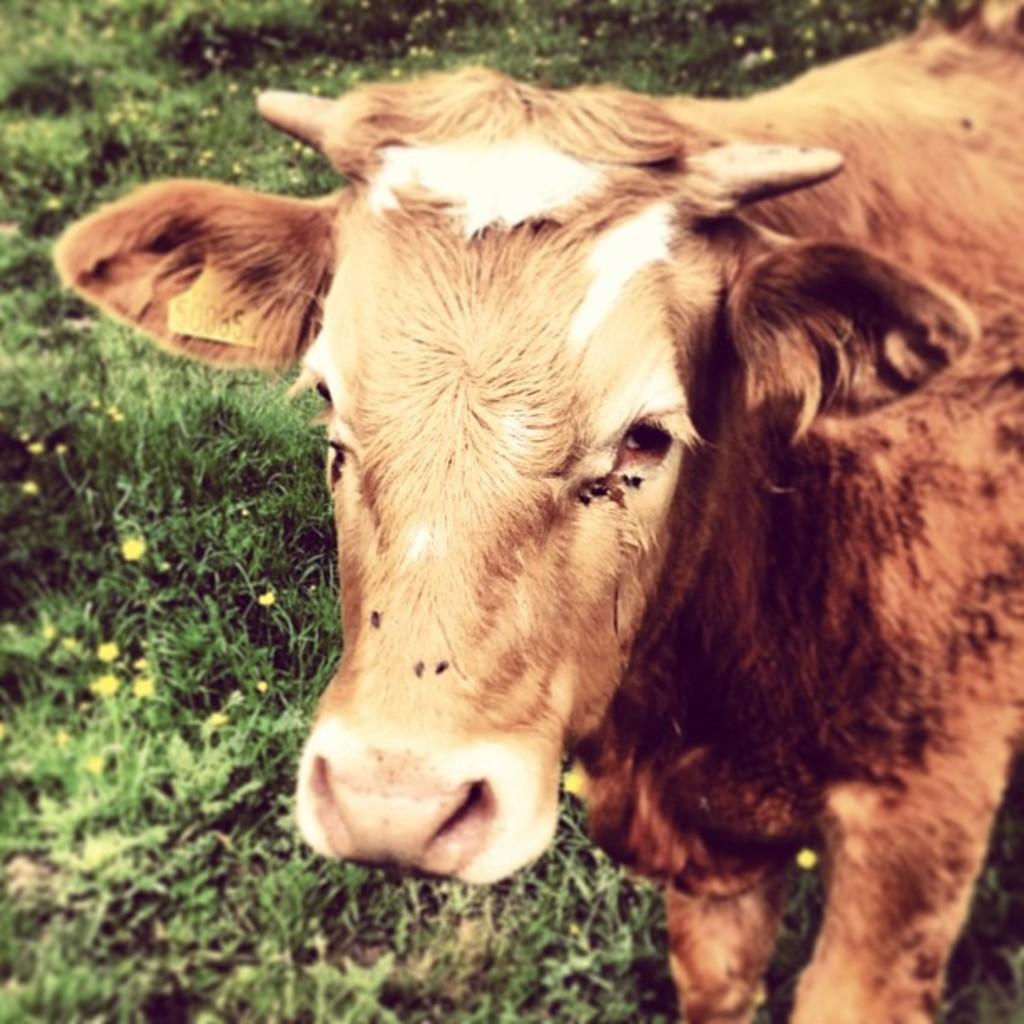What type of creature is in the image? There is an animal in the image. Can you describe the color pattern of the animal? The animal has brown and white colors. What type of flora can be seen in the image? There are yellow color flowers in the image. What type of vegetation is visible in the image? There is grass visible in the image. What type of gun is being used to celebrate the birthday in the image? There is no gun or birthday celebration present in the image; it features an animal with brown and white colors, yellow flowers, and grass. 